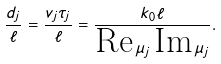Convert formula to latex. <formula><loc_0><loc_0><loc_500><loc_500>\frac { d _ { j } } { \ell } = \frac { v _ { j } \tau _ { j } } { \ell } = \frac { k _ { 0 } \ell } { \text {Re} \, \mu _ { j } \, \text {Im} \, \mu _ { j } } .</formula> 